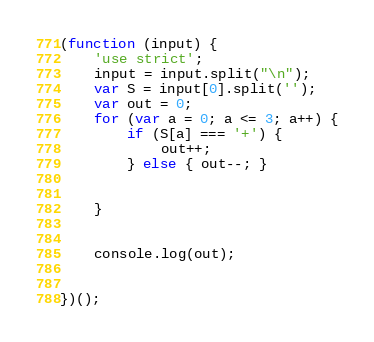<code> <loc_0><loc_0><loc_500><loc_500><_JavaScript_>(function (input) {
    'use strict';
    input = input.split("\n");
    var S = input[0].split('');
    var out = 0;
    for (var a = 0; a <= 3; a++) {
        if (S[a] === '+') {
            out++;
        } else { out--; }


    }


    console.log(out);


})();</code> 